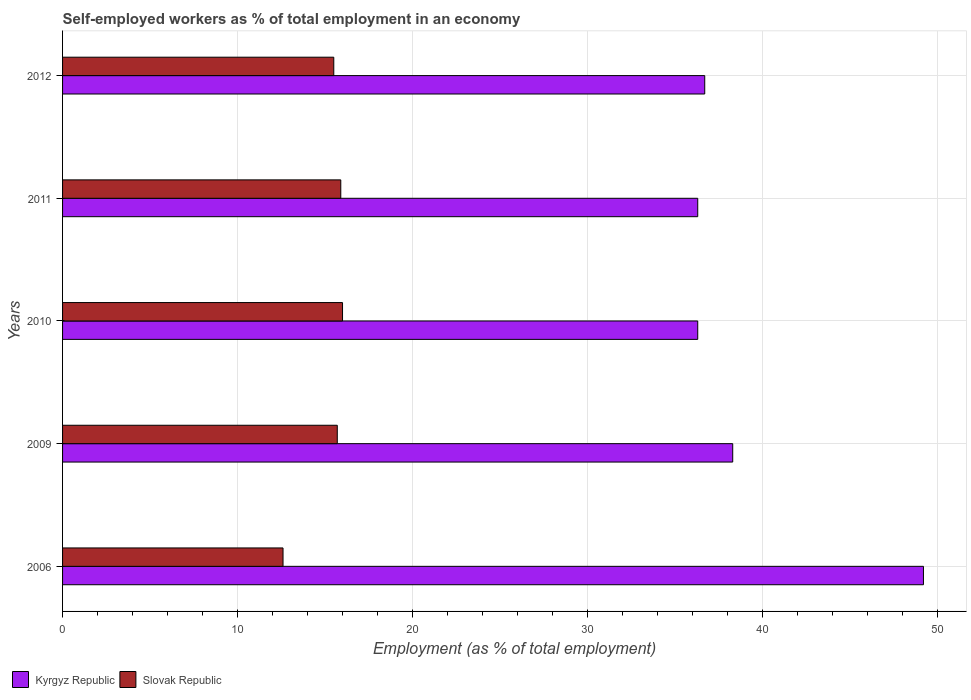How many different coloured bars are there?
Provide a short and direct response. 2. Are the number of bars on each tick of the Y-axis equal?
Your answer should be compact. Yes. How many bars are there on the 5th tick from the bottom?
Provide a succinct answer. 2. What is the label of the 5th group of bars from the top?
Your response must be concise. 2006. In how many cases, is the number of bars for a given year not equal to the number of legend labels?
Offer a terse response. 0. What is the percentage of self-employed workers in Kyrgyz Republic in 2011?
Your answer should be very brief. 36.3. Across all years, what is the maximum percentage of self-employed workers in Slovak Republic?
Your answer should be very brief. 16. Across all years, what is the minimum percentage of self-employed workers in Slovak Republic?
Offer a terse response. 12.6. What is the total percentage of self-employed workers in Kyrgyz Republic in the graph?
Give a very brief answer. 196.8. What is the difference between the percentage of self-employed workers in Kyrgyz Republic in 2006 and the percentage of self-employed workers in Slovak Republic in 2011?
Provide a short and direct response. 33.3. What is the average percentage of self-employed workers in Kyrgyz Republic per year?
Ensure brevity in your answer.  39.36. In the year 2009, what is the difference between the percentage of self-employed workers in Slovak Republic and percentage of self-employed workers in Kyrgyz Republic?
Make the answer very short. -22.6. What is the ratio of the percentage of self-employed workers in Kyrgyz Republic in 2006 to that in 2010?
Ensure brevity in your answer.  1.36. Is the percentage of self-employed workers in Kyrgyz Republic in 2006 less than that in 2010?
Your answer should be compact. No. What is the difference between the highest and the second highest percentage of self-employed workers in Slovak Republic?
Your answer should be compact. 0.1. What is the difference between the highest and the lowest percentage of self-employed workers in Kyrgyz Republic?
Your response must be concise. 12.9. In how many years, is the percentage of self-employed workers in Slovak Republic greater than the average percentage of self-employed workers in Slovak Republic taken over all years?
Provide a succinct answer. 4. Is the sum of the percentage of self-employed workers in Kyrgyz Republic in 2011 and 2012 greater than the maximum percentage of self-employed workers in Slovak Republic across all years?
Provide a short and direct response. Yes. What does the 2nd bar from the top in 2011 represents?
Ensure brevity in your answer.  Kyrgyz Republic. What does the 1st bar from the bottom in 2010 represents?
Give a very brief answer. Kyrgyz Republic. How many bars are there?
Your response must be concise. 10. Are all the bars in the graph horizontal?
Your answer should be compact. Yes. Are the values on the major ticks of X-axis written in scientific E-notation?
Ensure brevity in your answer.  No. Does the graph contain any zero values?
Give a very brief answer. No. Does the graph contain grids?
Provide a short and direct response. Yes. How many legend labels are there?
Your response must be concise. 2. What is the title of the graph?
Provide a succinct answer. Self-employed workers as % of total employment in an economy. Does "Niger" appear as one of the legend labels in the graph?
Give a very brief answer. No. What is the label or title of the X-axis?
Offer a terse response. Employment (as % of total employment). What is the Employment (as % of total employment) of Kyrgyz Republic in 2006?
Ensure brevity in your answer.  49.2. What is the Employment (as % of total employment) of Slovak Republic in 2006?
Ensure brevity in your answer.  12.6. What is the Employment (as % of total employment) in Kyrgyz Republic in 2009?
Provide a succinct answer. 38.3. What is the Employment (as % of total employment) in Slovak Republic in 2009?
Your response must be concise. 15.7. What is the Employment (as % of total employment) of Kyrgyz Republic in 2010?
Your answer should be very brief. 36.3. What is the Employment (as % of total employment) in Slovak Republic in 2010?
Your response must be concise. 16. What is the Employment (as % of total employment) of Kyrgyz Republic in 2011?
Make the answer very short. 36.3. What is the Employment (as % of total employment) in Slovak Republic in 2011?
Give a very brief answer. 15.9. What is the Employment (as % of total employment) in Kyrgyz Republic in 2012?
Give a very brief answer. 36.7. Across all years, what is the maximum Employment (as % of total employment) of Kyrgyz Republic?
Offer a terse response. 49.2. Across all years, what is the maximum Employment (as % of total employment) of Slovak Republic?
Your response must be concise. 16. Across all years, what is the minimum Employment (as % of total employment) in Kyrgyz Republic?
Offer a terse response. 36.3. Across all years, what is the minimum Employment (as % of total employment) of Slovak Republic?
Provide a succinct answer. 12.6. What is the total Employment (as % of total employment) of Kyrgyz Republic in the graph?
Keep it short and to the point. 196.8. What is the total Employment (as % of total employment) of Slovak Republic in the graph?
Your answer should be very brief. 75.7. What is the difference between the Employment (as % of total employment) in Kyrgyz Republic in 2006 and that in 2009?
Offer a terse response. 10.9. What is the difference between the Employment (as % of total employment) of Slovak Republic in 2006 and that in 2009?
Keep it short and to the point. -3.1. What is the difference between the Employment (as % of total employment) in Slovak Republic in 2006 and that in 2010?
Your answer should be compact. -3.4. What is the difference between the Employment (as % of total employment) of Slovak Republic in 2006 and that in 2011?
Give a very brief answer. -3.3. What is the difference between the Employment (as % of total employment) in Slovak Republic in 2006 and that in 2012?
Make the answer very short. -2.9. What is the difference between the Employment (as % of total employment) in Slovak Republic in 2009 and that in 2010?
Offer a very short reply. -0.3. What is the difference between the Employment (as % of total employment) of Kyrgyz Republic in 2009 and that in 2011?
Provide a short and direct response. 2. What is the difference between the Employment (as % of total employment) in Slovak Republic in 2009 and that in 2011?
Your answer should be very brief. -0.2. What is the difference between the Employment (as % of total employment) in Kyrgyz Republic in 2010 and that in 2011?
Your answer should be compact. 0. What is the difference between the Employment (as % of total employment) of Slovak Republic in 2010 and that in 2011?
Ensure brevity in your answer.  0.1. What is the difference between the Employment (as % of total employment) in Kyrgyz Republic in 2010 and that in 2012?
Ensure brevity in your answer.  -0.4. What is the difference between the Employment (as % of total employment) in Kyrgyz Republic in 2011 and that in 2012?
Give a very brief answer. -0.4. What is the difference between the Employment (as % of total employment) in Slovak Republic in 2011 and that in 2012?
Provide a succinct answer. 0.4. What is the difference between the Employment (as % of total employment) in Kyrgyz Republic in 2006 and the Employment (as % of total employment) in Slovak Republic in 2009?
Your answer should be compact. 33.5. What is the difference between the Employment (as % of total employment) in Kyrgyz Republic in 2006 and the Employment (as % of total employment) in Slovak Republic in 2010?
Offer a very short reply. 33.2. What is the difference between the Employment (as % of total employment) of Kyrgyz Republic in 2006 and the Employment (as % of total employment) of Slovak Republic in 2011?
Your answer should be very brief. 33.3. What is the difference between the Employment (as % of total employment) in Kyrgyz Republic in 2006 and the Employment (as % of total employment) in Slovak Republic in 2012?
Offer a very short reply. 33.7. What is the difference between the Employment (as % of total employment) of Kyrgyz Republic in 2009 and the Employment (as % of total employment) of Slovak Republic in 2010?
Provide a succinct answer. 22.3. What is the difference between the Employment (as % of total employment) of Kyrgyz Republic in 2009 and the Employment (as % of total employment) of Slovak Republic in 2011?
Ensure brevity in your answer.  22.4. What is the difference between the Employment (as % of total employment) of Kyrgyz Republic in 2009 and the Employment (as % of total employment) of Slovak Republic in 2012?
Offer a terse response. 22.8. What is the difference between the Employment (as % of total employment) in Kyrgyz Republic in 2010 and the Employment (as % of total employment) in Slovak Republic in 2011?
Make the answer very short. 20.4. What is the difference between the Employment (as % of total employment) of Kyrgyz Republic in 2010 and the Employment (as % of total employment) of Slovak Republic in 2012?
Your response must be concise. 20.8. What is the difference between the Employment (as % of total employment) of Kyrgyz Republic in 2011 and the Employment (as % of total employment) of Slovak Republic in 2012?
Your response must be concise. 20.8. What is the average Employment (as % of total employment) of Kyrgyz Republic per year?
Provide a short and direct response. 39.36. What is the average Employment (as % of total employment) of Slovak Republic per year?
Offer a very short reply. 15.14. In the year 2006, what is the difference between the Employment (as % of total employment) of Kyrgyz Republic and Employment (as % of total employment) of Slovak Republic?
Your answer should be very brief. 36.6. In the year 2009, what is the difference between the Employment (as % of total employment) in Kyrgyz Republic and Employment (as % of total employment) in Slovak Republic?
Provide a short and direct response. 22.6. In the year 2010, what is the difference between the Employment (as % of total employment) in Kyrgyz Republic and Employment (as % of total employment) in Slovak Republic?
Make the answer very short. 20.3. In the year 2011, what is the difference between the Employment (as % of total employment) in Kyrgyz Republic and Employment (as % of total employment) in Slovak Republic?
Your response must be concise. 20.4. In the year 2012, what is the difference between the Employment (as % of total employment) of Kyrgyz Republic and Employment (as % of total employment) of Slovak Republic?
Give a very brief answer. 21.2. What is the ratio of the Employment (as % of total employment) in Kyrgyz Republic in 2006 to that in 2009?
Your answer should be very brief. 1.28. What is the ratio of the Employment (as % of total employment) of Slovak Republic in 2006 to that in 2009?
Offer a terse response. 0.8. What is the ratio of the Employment (as % of total employment) in Kyrgyz Republic in 2006 to that in 2010?
Offer a terse response. 1.36. What is the ratio of the Employment (as % of total employment) of Slovak Republic in 2006 to that in 2010?
Offer a terse response. 0.79. What is the ratio of the Employment (as % of total employment) in Kyrgyz Republic in 2006 to that in 2011?
Offer a very short reply. 1.36. What is the ratio of the Employment (as % of total employment) in Slovak Republic in 2006 to that in 2011?
Keep it short and to the point. 0.79. What is the ratio of the Employment (as % of total employment) in Kyrgyz Republic in 2006 to that in 2012?
Provide a succinct answer. 1.34. What is the ratio of the Employment (as % of total employment) in Slovak Republic in 2006 to that in 2012?
Your response must be concise. 0.81. What is the ratio of the Employment (as % of total employment) in Kyrgyz Republic in 2009 to that in 2010?
Make the answer very short. 1.06. What is the ratio of the Employment (as % of total employment) in Slovak Republic in 2009 to that in 2010?
Ensure brevity in your answer.  0.98. What is the ratio of the Employment (as % of total employment) in Kyrgyz Republic in 2009 to that in 2011?
Offer a terse response. 1.06. What is the ratio of the Employment (as % of total employment) in Slovak Republic in 2009 to that in 2011?
Offer a terse response. 0.99. What is the ratio of the Employment (as % of total employment) in Kyrgyz Republic in 2009 to that in 2012?
Offer a terse response. 1.04. What is the ratio of the Employment (as % of total employment) of Slovak Republic in 2009 to that in 2012?
Your answer should be compact. 1.01. What is the ratio of the Employment (as % of total employment) in Kyrgyz Republic in 2010 to that in 2011?
Your response must be concise. 1. What is the ratio of the Employment (as % of total employment) of Kyrgyz Republic in 2010 to that in 2012?
Offer a very short reply. 0.99. What is the ratio of the Employment (as % of total employment) in Slovak Republic in 2010 to that in 2012?
Offer a terse response. 1.03. What is the ratio of the Employment (as % of total employment) of Slovak Republic in 2011 to that in 2012?
Offer a very short reply. 1.03. What is the difference between the highest and the second highest Employment (as % of total employment) of Slovak Republic?
Provide a short and direct response. 0.1. What is the difference between the highest and the lowest Employment (as % of total employment) of Kyrgyz Republic?
Ensure brevity in your answer.  12.9. What is the difference between the highest and the lowest Employment (as % of total employment) of Slovak Republic?
Make the answer very short. 3.4. 